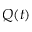<formula> <loc_0><loc_0><loc_500><loc_500>Q ( t )</formula> 